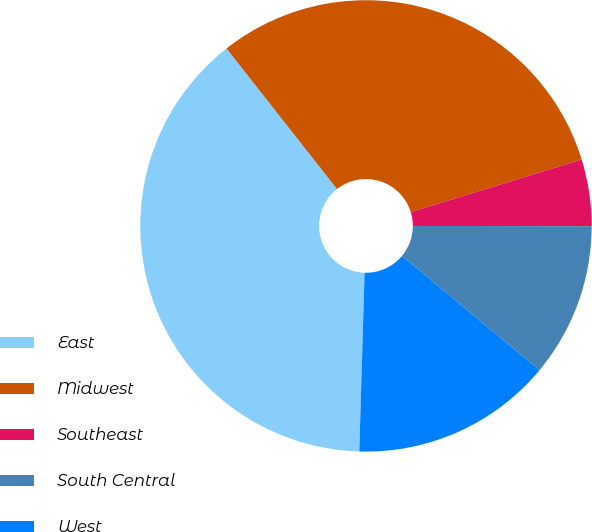Convert chart to OTSL. <chart><loc_0><loc_0><loc_500><loc_500><pie_chart><fcel>East<fcel>Midwest<fcel>Southeast<fcel>South Central<fcel>West<nl><fcel>38.93%<fcel>30.85%<fcel>4.77%<fcel>11.02%<fcel>14.43%<nl></chart> 